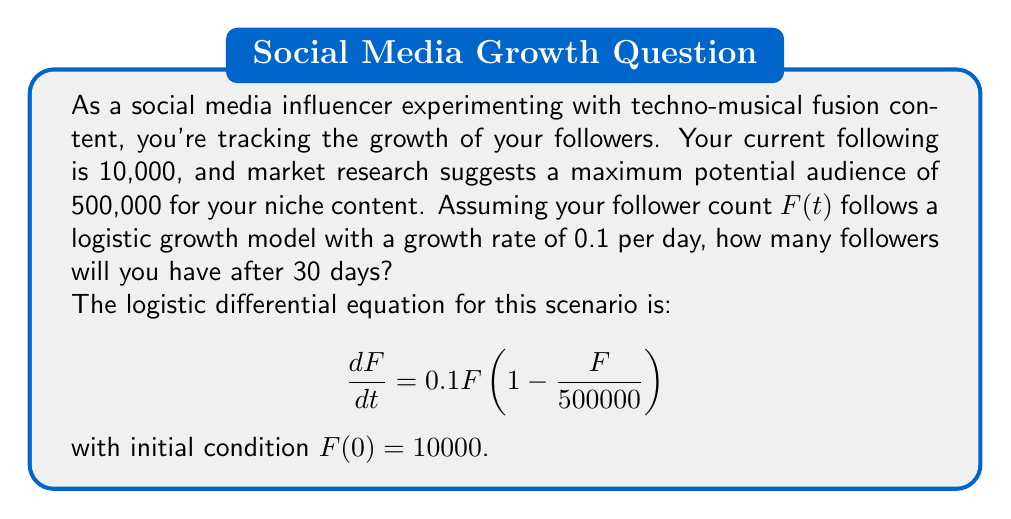Help me with this question. To solve this problem, we need to use the solution to the logistic differential equation:

$$F(t) = \frac{K}{1 + (\frac{K}{F_0} - 1)e^{-rt}}$$

Where:
- $K$ is the carrying capacity (maximum potential audience)
- $F_0$ is the initial number of followers
- $r$ is the growth rate
- $t$ is the time in days

Given:
- $K = 500000$
- $F_0 = 10000$
- $r = 0.1$
- $t = 30$

Let's substitute these values into the equation:

$$F(30) = \frac{500000}{1 + (\frac{500000}{10000} - 1)e^{-0.1(30)}}$$

Simplifying:

$$F(30) = \frac{500000}{1 + (49)e^{-3}}$$

Now, let's calculate:

1. $e^{-3} \approx 0.0498$
2. $49 * 0.0498 \approx 2.4402$
3. $1 + 2.4402 = 3.4402$

Substituting back:

$$F(30) = \frac{500000}{3.4402}$$

$$F(30) \approx 145,340$$

Therefore, after 30 days, you will have approximately 145,340 followers.
Answer: 145,340 followers (rounded to the nearest whole number) 